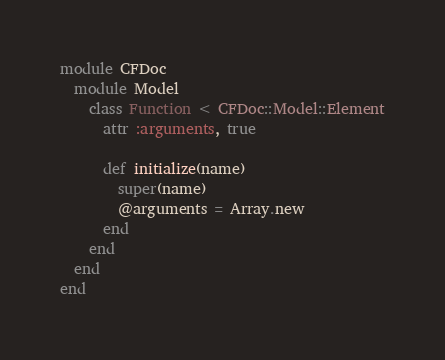Convert code to text. <code><loc_0><loc_0><loc_500><loc_500><_Ruby_>module CFDoc
  module Model
    class Function < CFDoc::Model::Element
      attr :arguments, true

      def initialize(name)
        super(name)
        @arguments = Array.new
      end
    end
  end
end
</code> 